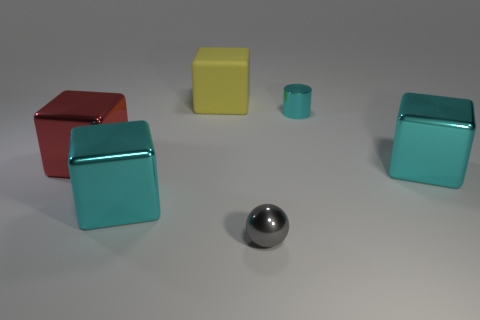If I were to categorize these objects by size, how would that look? You would have three categories: small objects would include the gray sphere and the small turquoise cylinder, medium objects would encompass the yellow cube, and large objects would be the red and larger turquoise cubes. 